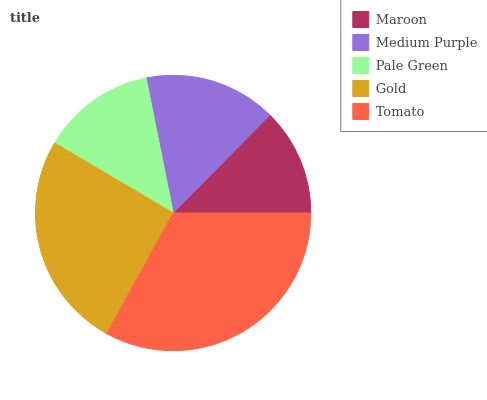Is Maroon the minimum?
Answer yes or no. Yes. Is Tomato the maximum?
Answer yes or no. Yes. Is Medium Purple the minimum?
Answer yes or no. No. Is Medium Purple the maximum?
Answer yes or no. No. Is Medium Purple greater than Maroon?
Answer yes or no. Yes. Is Maroon less than Medium Purple?
Answer yes or no. Yes. Is Maroon greater than Medium Purple?
Answer yes or no. No. Is Medium Purple less than Maroon?
Answer yes or no. No. Is Medium Purple the high median?
Answer yes or no. Yes. Is Medium Purple the low median?
Answer yes or no. Yes. Is Gold the high median?
Answer yes or no. No. Is Gold the low median?
Answer yes or no. No. 